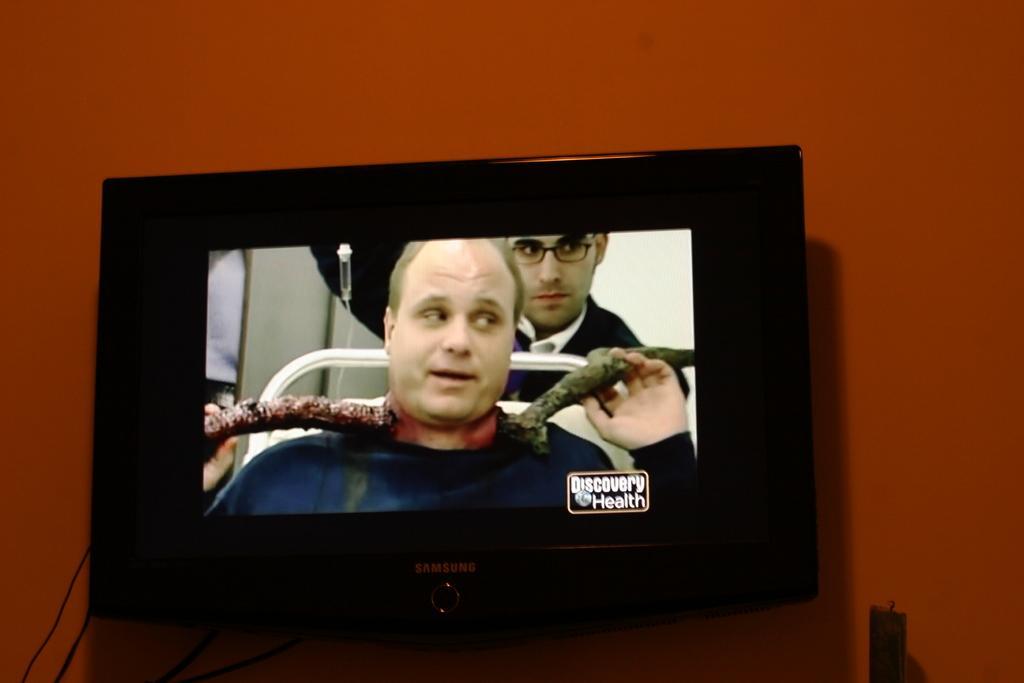How would you summarize this image in a sentence or two? In this image we can see a television. On the television we can see two men and some text written on it. In the background we can see wall. 